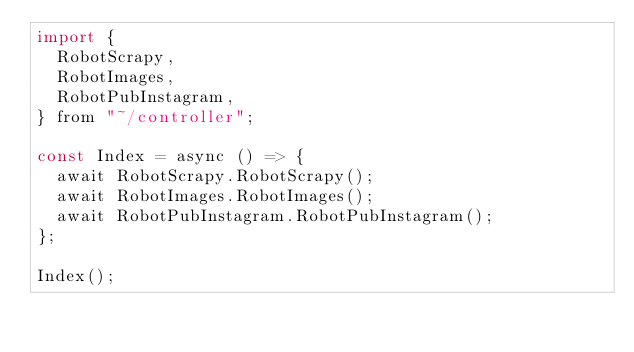<code> <loc_0><loc_0><loc_500><loc_500><_JavaScript_>import {
  RobotScrapy,
  RobotImages,
  RobotPubInstagram,
} from "~/controller";

const Index = async () => {
  await RobotScrapy.RobotScrapy();
  await RobotImages.RobotImages();
  await RobotPubInstagram.RobotPubInstagram();
};

Index();
</code> 